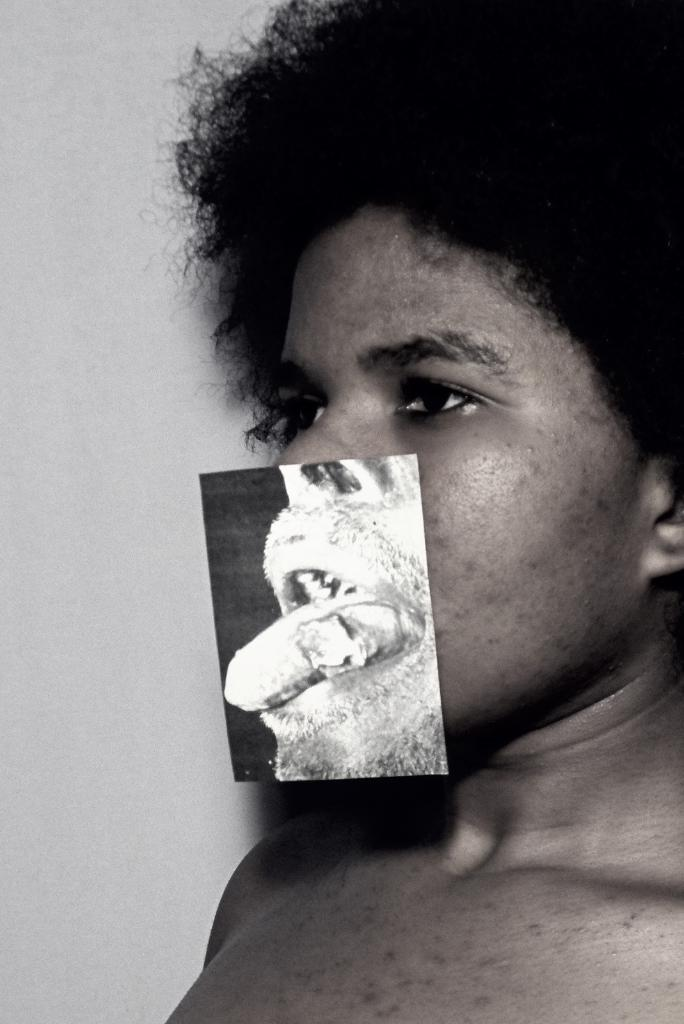What is the color scheme of the image? The image is black and white. Who is present in the image? There is a man in the image. What is unique about the man's face? There is a picture of a mouth on the man's face. What can be seen in the background of the image? There is a wall in the background of the image. How many goldfish are swimming in the man's mouth in the image? There are no goldfish present in the image, and the man's mouth is depicted as a picture, not a physical mouth. What type of fiction is the man reading in the image? There is no book or any indication of reading in the image. 